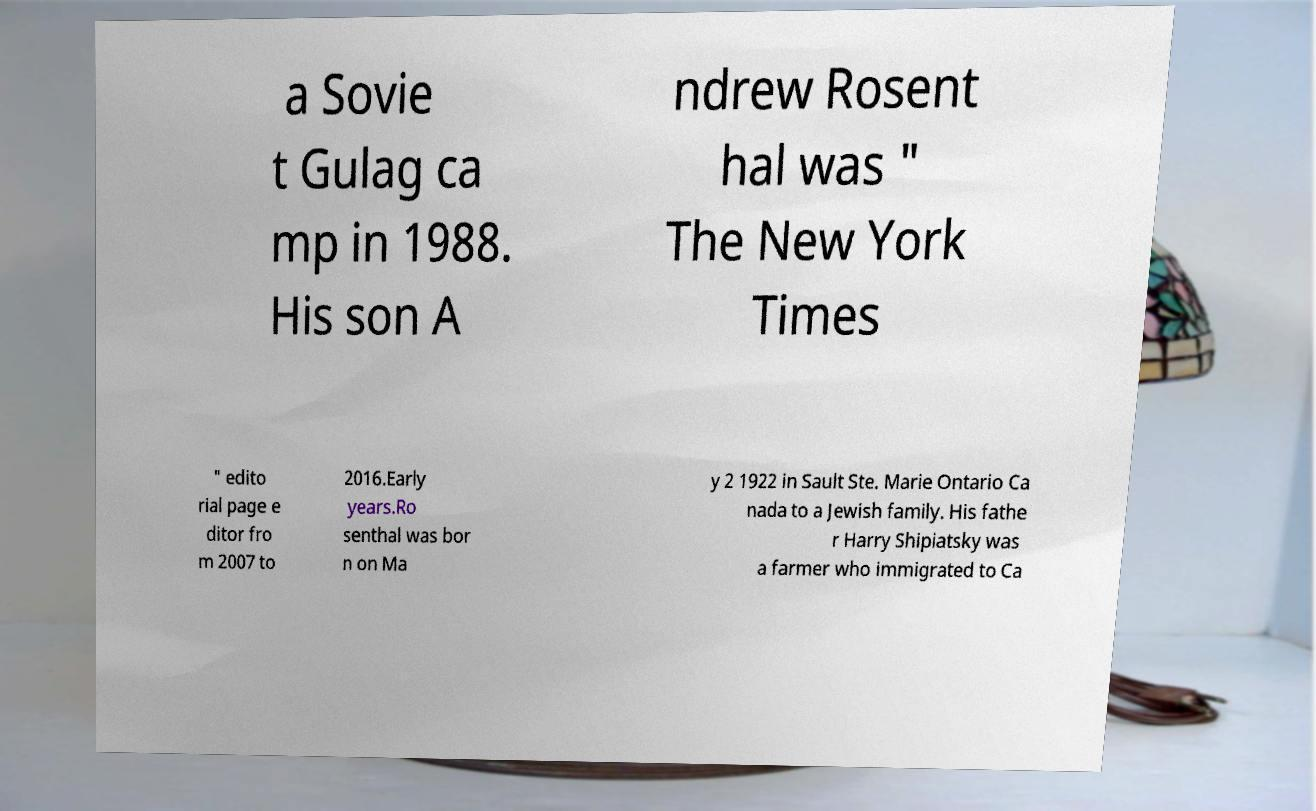Please read and relay the text visible in this image. What does it say? a Sovie t Gulag ca mp in 1988. His son A ndrew Rosent hal was " The New York Times " edito rial page e ditor fro m 2007 to 2016.Early years.Ro senthal was bor n on Ma y 2 1922 in Sault Ste. Marie Ontario Ca nada to a Jewish family. His fathe r Harry Shipiatsky was a farmer who immigrated to Ca 